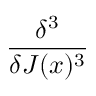<formula> <loc_0><loc_0><loc_500><loc_500>\frac { \delta ^ { 3 } } { \delta J ( x ) ^ { 3 } }</formula> 